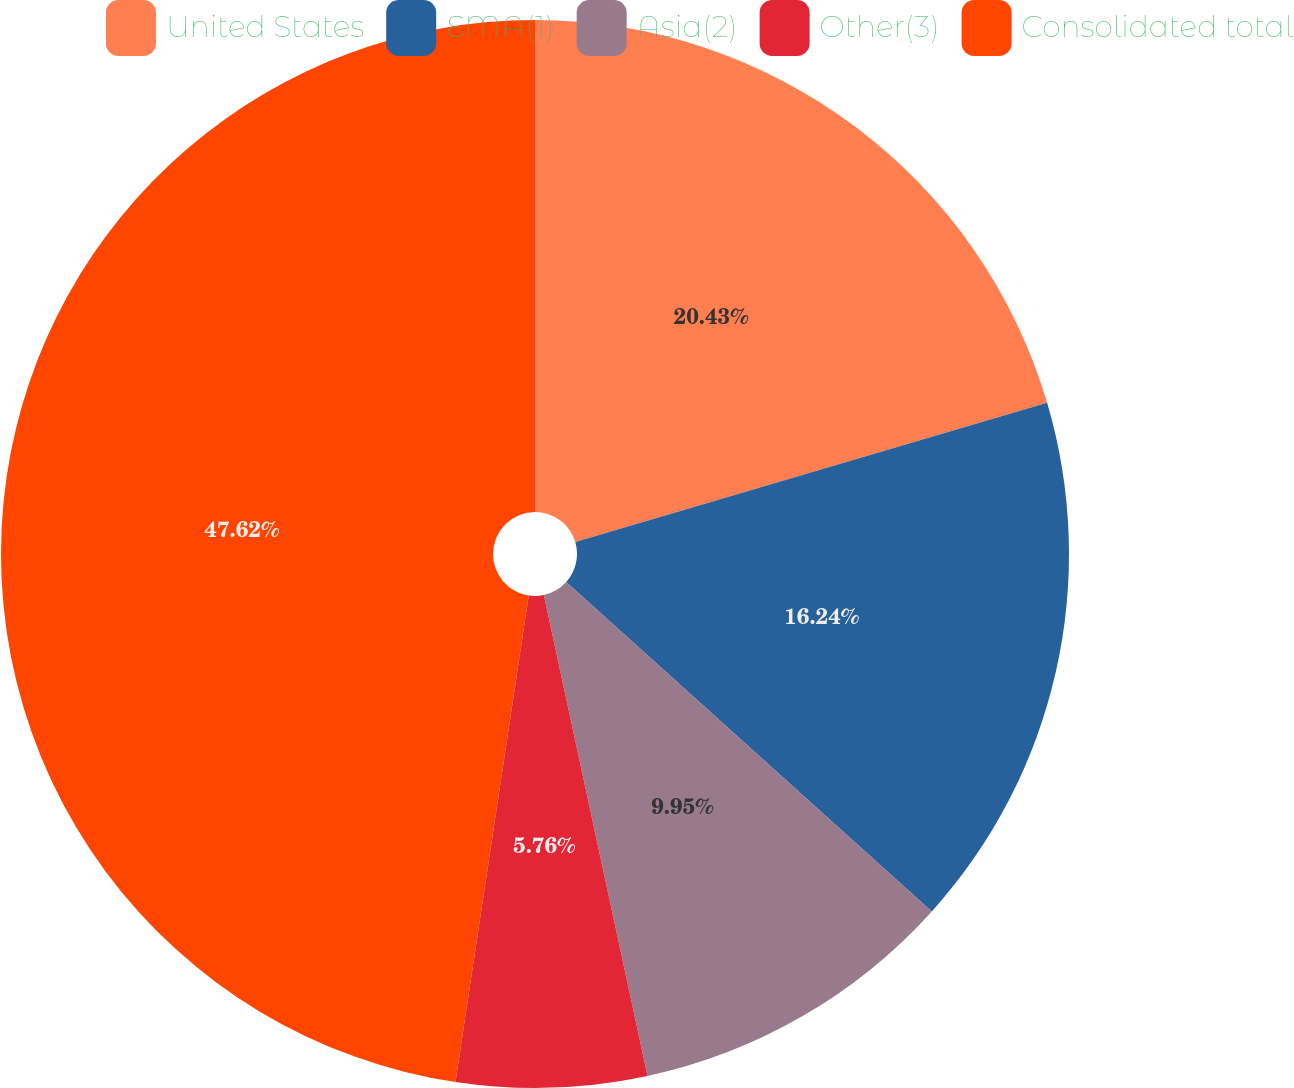<chart> <loc_0><loc_0><loc_500><loc_500><pie_chart><fcel>United States<fcel>EMA(1)<fcel>Asia(2)<fcel>Other(3)<fcel>Consolidated total<nl><fcel>20.43%<fcel>16.24%<fcel>9.95%<fcel>5.76%<fcel>47.62%<nl></chart> 